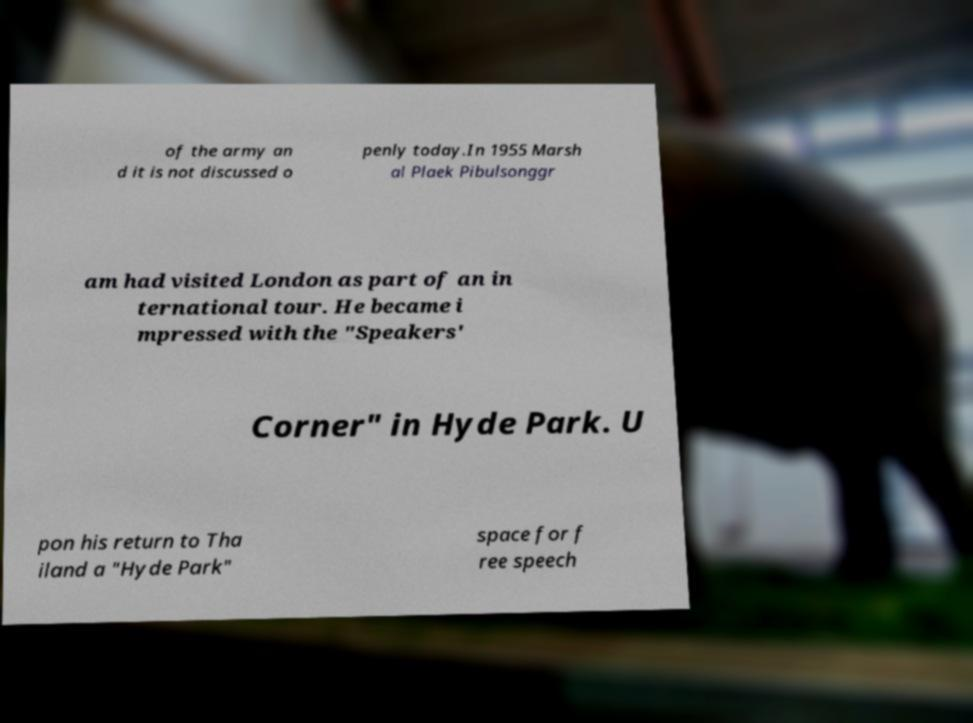Can you accurately transcribe the text from the provided image for me? of the army an d it is not discussed o penly today.In 1955 Marsh al Plaek Pibulsonggr am had visited London as part of an in ternational tour. He became i mpressed with the "Speakers' Corner" in Hyde Park. U pon his return to Tha iland a "Hyde Park" space for f ree speech 